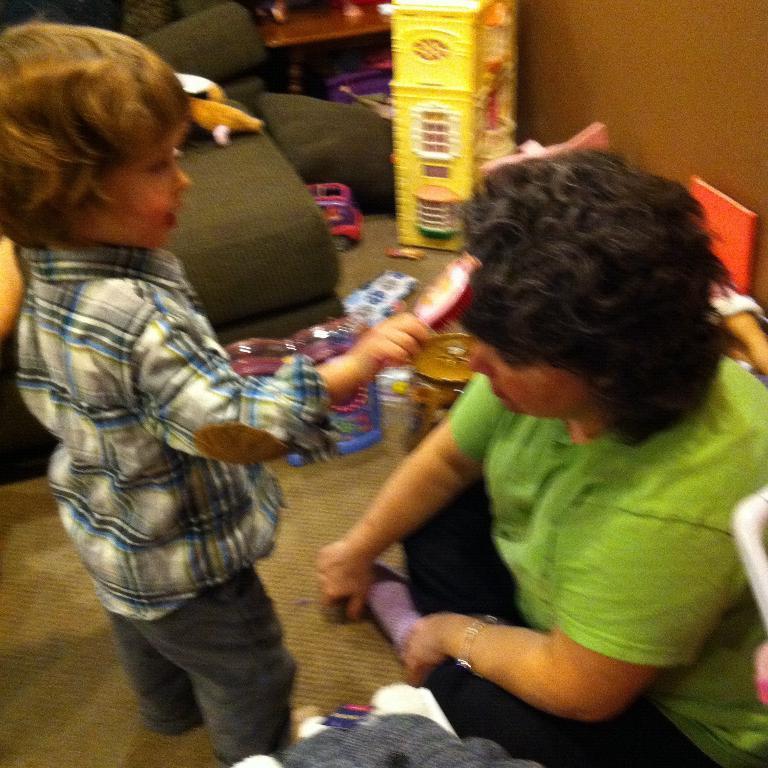How would you summarize this image in a sentence or two? In this image on the right side there is one person sitting, and on the left side there is one boy standing and he is holding something. And in the background there are some toys, wall, clothes and at the bottom there is floor. 